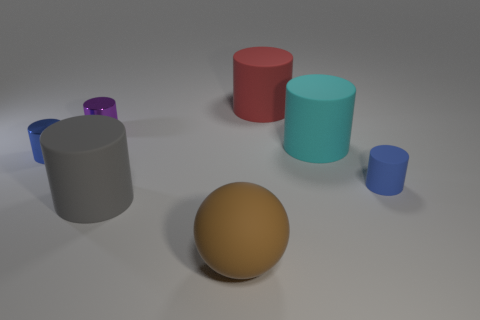Subtract 1 cylinders. How many cylinders are left? 5 Subtract all purple metal cylinders. How many cylinders are left? 5 Subtract all purple cylinders. How many cylinders are left? 5 Add 3 large red things. How many objects exist? 10 Subtract all blue cylinders. Subtract all cyan cubes. How many cylinders are left? 4 Subtract all cylinders. How many objects are left? 1 Subtract all small red cylinders. Subtract all large rubber objects. How many objects are left? 3 Add 2 gray objects. How many gray objects are left? 3 Add 7 tiny shiny blocks. How many tiny shiny blocks exist? 7 Subtract 0 yellow blocks. How many objects are left? 7 